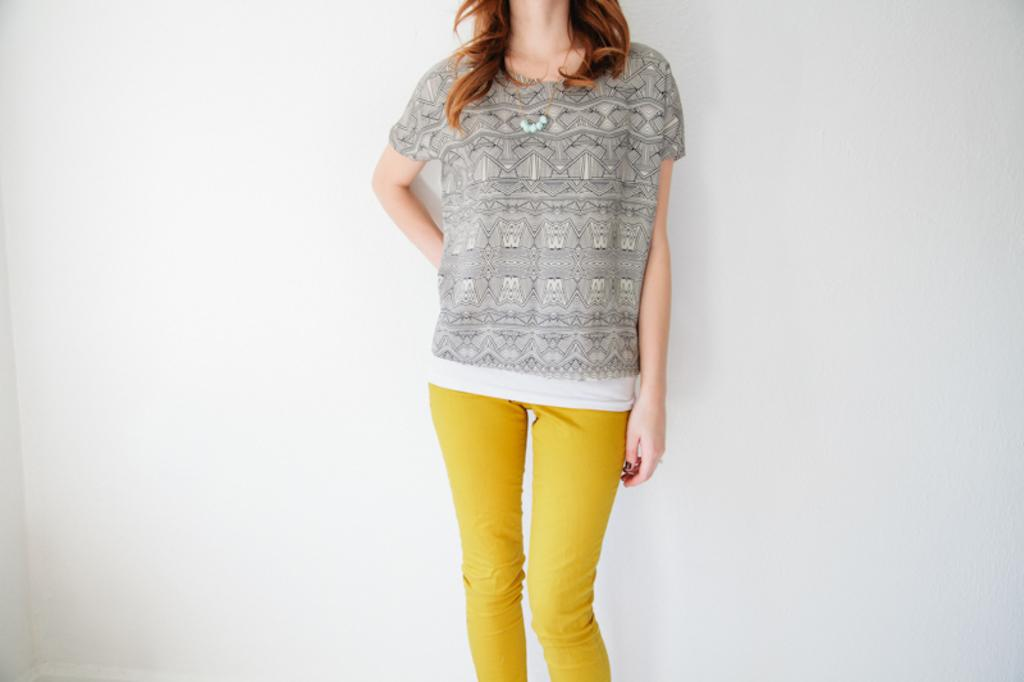What is the main subject of the image? The main subject of the image is a top. Who is the top intended for? The top is for a lady. What type of pants are visible in the image? There are yellow pants in the image. Who are the yellow pants intended for? The yellow pants are for a lady. What type of loss can be seen in the image? There is no loss visible in the image; it features a top and yellow pants. What type of land can be seen in the image? There is no land visible in the image; it features a top and yellow pants. 